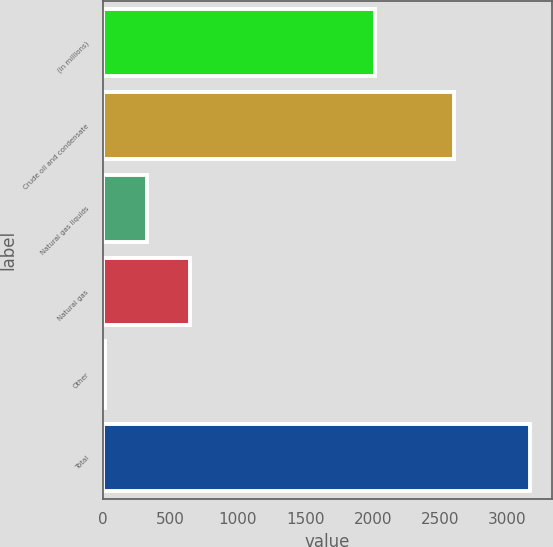Convert chart to OTSL. <chart><loc_0><loc_0><loc_500><loc_500><bar_chart><fcel>(In millions)<fcel>Crude oil and condensate<fcel>Natural gas liquids<fcel>Natural gas<fcel>Other<fcel>Total<nl><fcel>2016<fcel>2605<fcel>326.9<fcel>642.8<fcel>11<fcel>3170<nl></chart> 